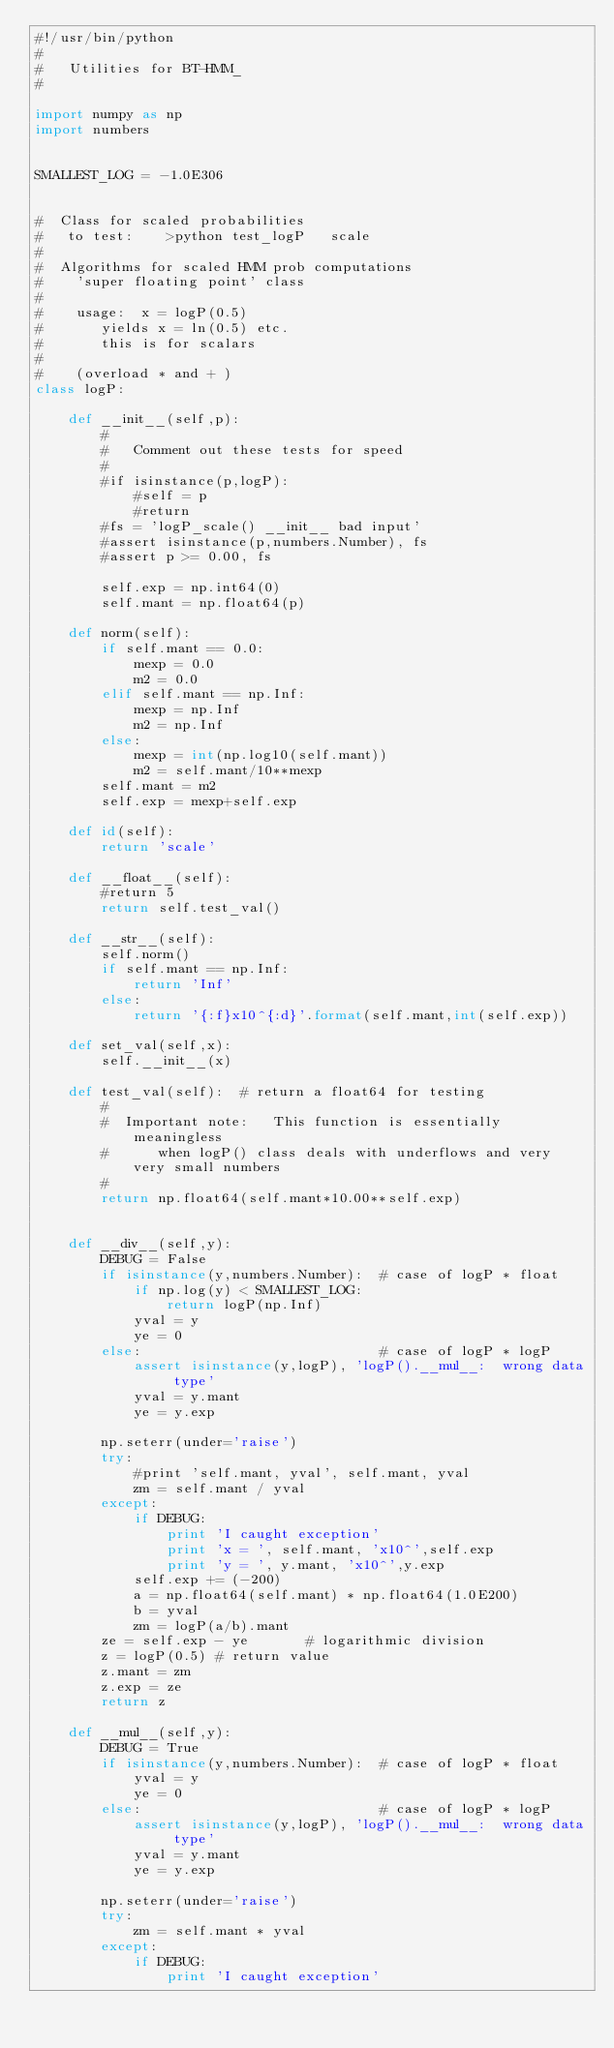Convert code to text. <code><loc_0><loc_0><loc_500><loc_500><_Python_>#!/usr/bin/python
#
#   Utilities for BT-HMM_
#

import numpy as np
import numbers


SMALLEST_LOG = -1.0E306


#  Class for scaled probabilities
#   to test:    >python test_logP   scale
#
#  Algorithms for scaled HMM prob computations
#    'super floating point' class
#
#    usage:  x = logP(0.5)
#       yields x = ln(0.5) etc.
#       this is for scalars
#
#    (overload * and + )
class logP:

    def __init__(self,p):
        #
        #   Comment out these tests for speed
        #
        #if isinstance(p,logP):
            #self = p
            #return
        #fs = 'logP_scale() __init__ bad input'
        #assert isinstance(p,numbers.Number), fs
        #assert p >= 0.00, fs
        
        self.exp = np.int64(0)
        self.mant = np.float64(p)

    def norm(self):
        if self.mant == 0.0:
            mexp = 0.0
            m2 = 0.0
        elif self.mant == np.Inf:
            mexp = np.Inf
            m2 = np.Inf
        else:
            mexp = int(np.log10(self.mant))
            m2 = self.mant/10**mexp
        self.mant = m2
        self.exp = mexp+self.exp

    def id(self):
        return 'scale'

    def __float__(self):
        #return 5
        return self.test_val()

    def __str__(self):
        self.norm()
        if self.mant == np.Inf:
            return 'Inf'
        else:
            return '{:f}x10^{:d}'.format(self.mant,int(self.exp))

    def set_val(self,x):
        self.__init__(x)

    def test_val(self):  # return a float64 for testing
        #
        #  Important note:   This function is essentially meaningless 
        #      when logP() class deals with underflows and very very small numbers
        #        
        return np.float64(self.mant*10.00**self.exp)


    def __div__(self,y):
        DEBUG = False
        if isinstance(y,numbers.Number):  # case of logP * float
            if np.log(y) < SMALLEST_LOG:
                return logP(np.Inf)
            yval = y
            ye = 0
        else:                             # case of logP * logP
            assert isinstance(y,logP), 'logP().__mul__:  wrong data type'
            yval = y.mant
            ye = y.exp

        np.seterr(under='raise')
        try:
            #print 'self.mant, yval', self.mant, yval
            zm = self.mant / yval
        except:
            if DEBUG:
                print 'I caught exception'
                print 'x = ', self.mant, 'x10^',self.exp
                print 'y = ', y.mant, 'x10^',y.exp
            self.exp += (-200)
            a = np.float64(self.mant) * np.float64(1.0E200)
            b = yval
            zm = logP(a/b).mant
        ze = self.exp - ye       # logarithmic division
        z = logP(0.5) # return value
        z.mant = zm
        z.exp = ze
        return z

    def __mul__(self,y):
        DEBUG = True
        if isinstance(y,numbers.Number):  # case of logP * float
            yval = y
            ye = 0
        else:                             # case of logP * logP
            assert isinstance(y,logP), 'logP().__mul__:  wrong data type'
            yval = y.mant
            ye = y.exp

        np.seterr(under='raise')
        try:
            zm = self.mant * yval
        except:
            if DEBUG:
                print 'I caught exception'</code> 